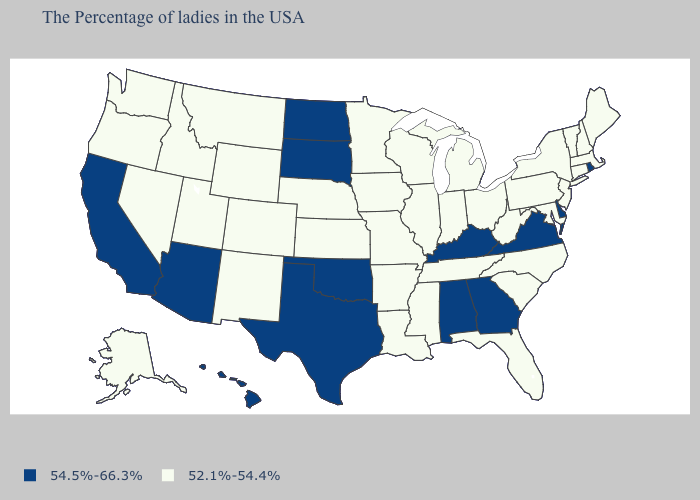Among the states that border Wyoming , does South Dakota have the lowest value?
Concise answer only. No. What is the lowest value in the USA?
Write a very short answer. 52.1%-54.4%. Name the states that have a value in the range 52.1%-54.4%?
Keep it brief. Maine, Massachusetts, New Hampshire, Vermont, Connecticut, New York, New Jersey, Maryland, Pennsylvania, North Carolina, South Carolina, West Virginia, Ohio, Florida, Michigan, Indiana, Tennessee, Wisconsin, Illinois, Mississippi, Louisiana, Missouri, Arkansas, Minnesota, Iowa, Kansas, Nebraska, Wyoming, Colorado, New Mexico, Utah, Montana, Idaho, Nevada, Washington, Oregon, Alaska. How many symbols are there in the legend?
Answer briefly. 2. What is the highest value in the USA?
Write a very short answer. 54.5%-66.3%. What is the highest value in the West ?
Be succinct. 54.5%-66.3%. Name the states that have a value in the range 54.5%-66.3%?
Short answer required. Rhode Island, Delaware, Virginia, Georgia, Kentucky, Alabama, Oklahoma, Texas, South Dakota, North Dakota, Arizona, California, Hawaii. What is the highest value in the South ?
Be succinct. 54.5%-66.3%. Name the states that have a value in the range 52.1%-54.4%?
Quick response, please. Maine, Massachusetts, New Hampshire, Vermont, Connecticut, New York, New Jersey, Maryland, Pennsylvania, North Carolina, South Carolina, West Virginia, Ohio, Florida, Michigan, Indiana, Tennessee, Wisconsin, Illinois, Mississippi, Louisiana, Missouri, Arkansas, Minnesota, Iowa, Kansas, Nebraska, Wyoming, Colorado, New Mexico, Utah, Montana, Idaho, Nevada, Washington, Oregon, Alaska. Name the states that have a value in the range 52.1%-54.4%?
Quick response, please. Maine, Massachusetts, New Hampshire, Vermont, Connecticut, New York, New Jersey, Maryland, Pennsylvania, North Carolina, South Carolina, West Virginia, Ohio, Florida, Michigan, Indiana, Tennessee, Wisconsin, Illinois, Mississippi, Louisiana, Missouri, Arkansas, Minnesota, Iowa, Kansas, Nebraska, Wyoming, Colorado, New Mexico, Utah, Montana, Idaho, Nevada, Washington, Oregon, Alaska. What is the highest value in states that border Alabama?
Quick response, please. 54.5%-66.3%. Among the states that border Oklahoma , which have the highest value?
Write a very short answer. Texas. What is the value of Maryland?
Concise answer only. 52.1%-54.4%. Does Nebraska have the highest value in the MidWest?
Write a very short answer. No. Does Alaska have the lowest value in the USA?
Keep it brief. Yes. 